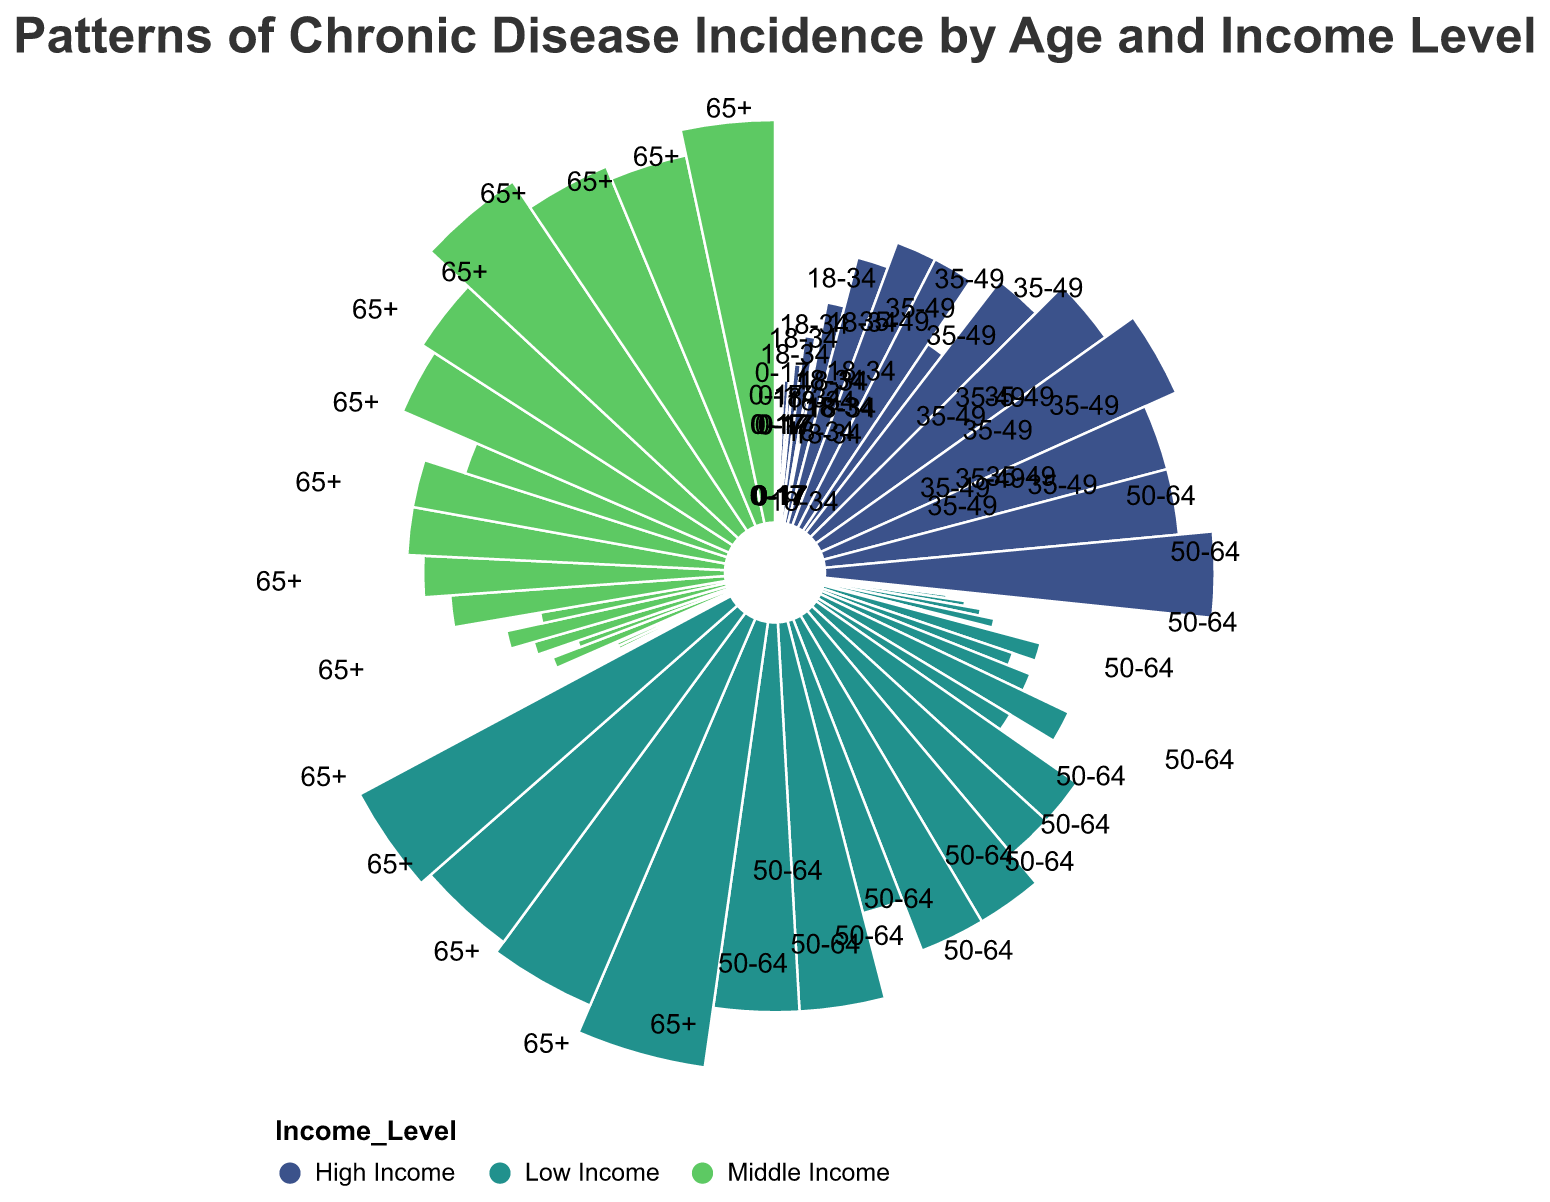How many types of diseases are displayed in the chart? There are five types of diseases displayed: Cardiovascular Disease, Diabetes, Chronic Respiratory Diseases, Arthritis, and Depression, which can be determined by observing the labels or the legend in the chart.
Answer: 5 Which age group has the highest incidence of Depression among low-income individuals? The chart indicates that the 65+ age group has the highest incidence of Depression among low-income individuals.
Answer: 65+ What is the combined incidence of Diabetes and Arthritis for the 50-64 age group with middle income? From the chart, the incidence of Diabetes is 20 and Arthritis is 15 for the 50-64 age group with a middle income. Summing these up gives 20 + 15 = 35.
Answer: 35 Which income level has the lowest incidence of Cardiovascular Disease in the 18-34 age group? The chart shows that the High Income group has the lowest incidence of Cardiovascular Disease in the 18-34 age category.
Answer: High Income By how much does the incidence of Chronic Respiratory Diseases in high-income individuals aged 65+ exceed that in high-income individuals aged 18-34? The incidence of Chronic Respiratory Diseases is 25 for high-income individuals aged 65+ and 2 for those aged 18-34. Calculating the difference gives 25 - 2 = 23.
Answer: 23 What is the pattern of Arthritis incidence by age for middle-income groups? Observing the chart, the pattern shows arthritis incidence increasing with age as follows: 0 for 0-17, 1 for 18-34, 7 for 35-49, 15 for 50-64, and 28 for 65+.
Answer: Incidence increases with age How does the incidence of Chronic Respiratory Diseases compare between low and middle-income groups in the 35-49 age range? The chart indicates an incidence of 15 for low-income and 10 for middle-income groups in the 35-49 age range, showing that it is higher in the low-income group.
Answer: Higher in low-income group Which disease has the highest overall incidence in the 35-49 age group across all income levels? By examining the chart for the 35-49 age group across all income levels, Depression has the highest incidence.
Answer: Depression To what extent does the incidence of Diabetes in high-income 50-64 age group individuals differ from that in low-income individuals of the same age group? The incidence of Diabetes is 18 in high-income and 25 in low-income individuals of the 50-64 age group. The difference is 25 - 18 = 7.
Answer: 7 What is the comparative incidence of Cardiovascular Disease for individuals aged 0-17 across all income levels? The chart shows that incidence of Cardiovascular Disease is 2 for low-income, 1 for middle-income, and 1 for high-income individuals aged 0-17. Thus, it's highest in the low-income group.
Answer: Highest in low-income group 